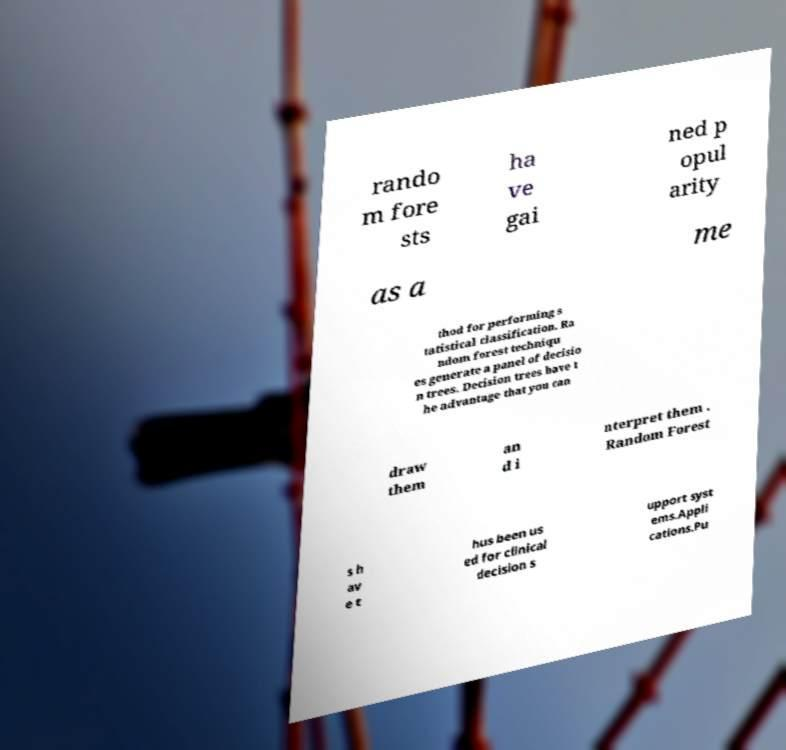There's text embedded in this image that I need extracted. Can you transcribe it verbatim? rando m fore sts ha ve gai ned p opul arity as a me thod for performing s tatistical classification. Ra ndom forest techniqu es generate a panel of decisio n trees. Decision trees have t he advantage that you can draw them an d i nterpret them . Random Forest s h av e t hus been us ed for clinical decision s upport syst ems.Appli cations.Pu 